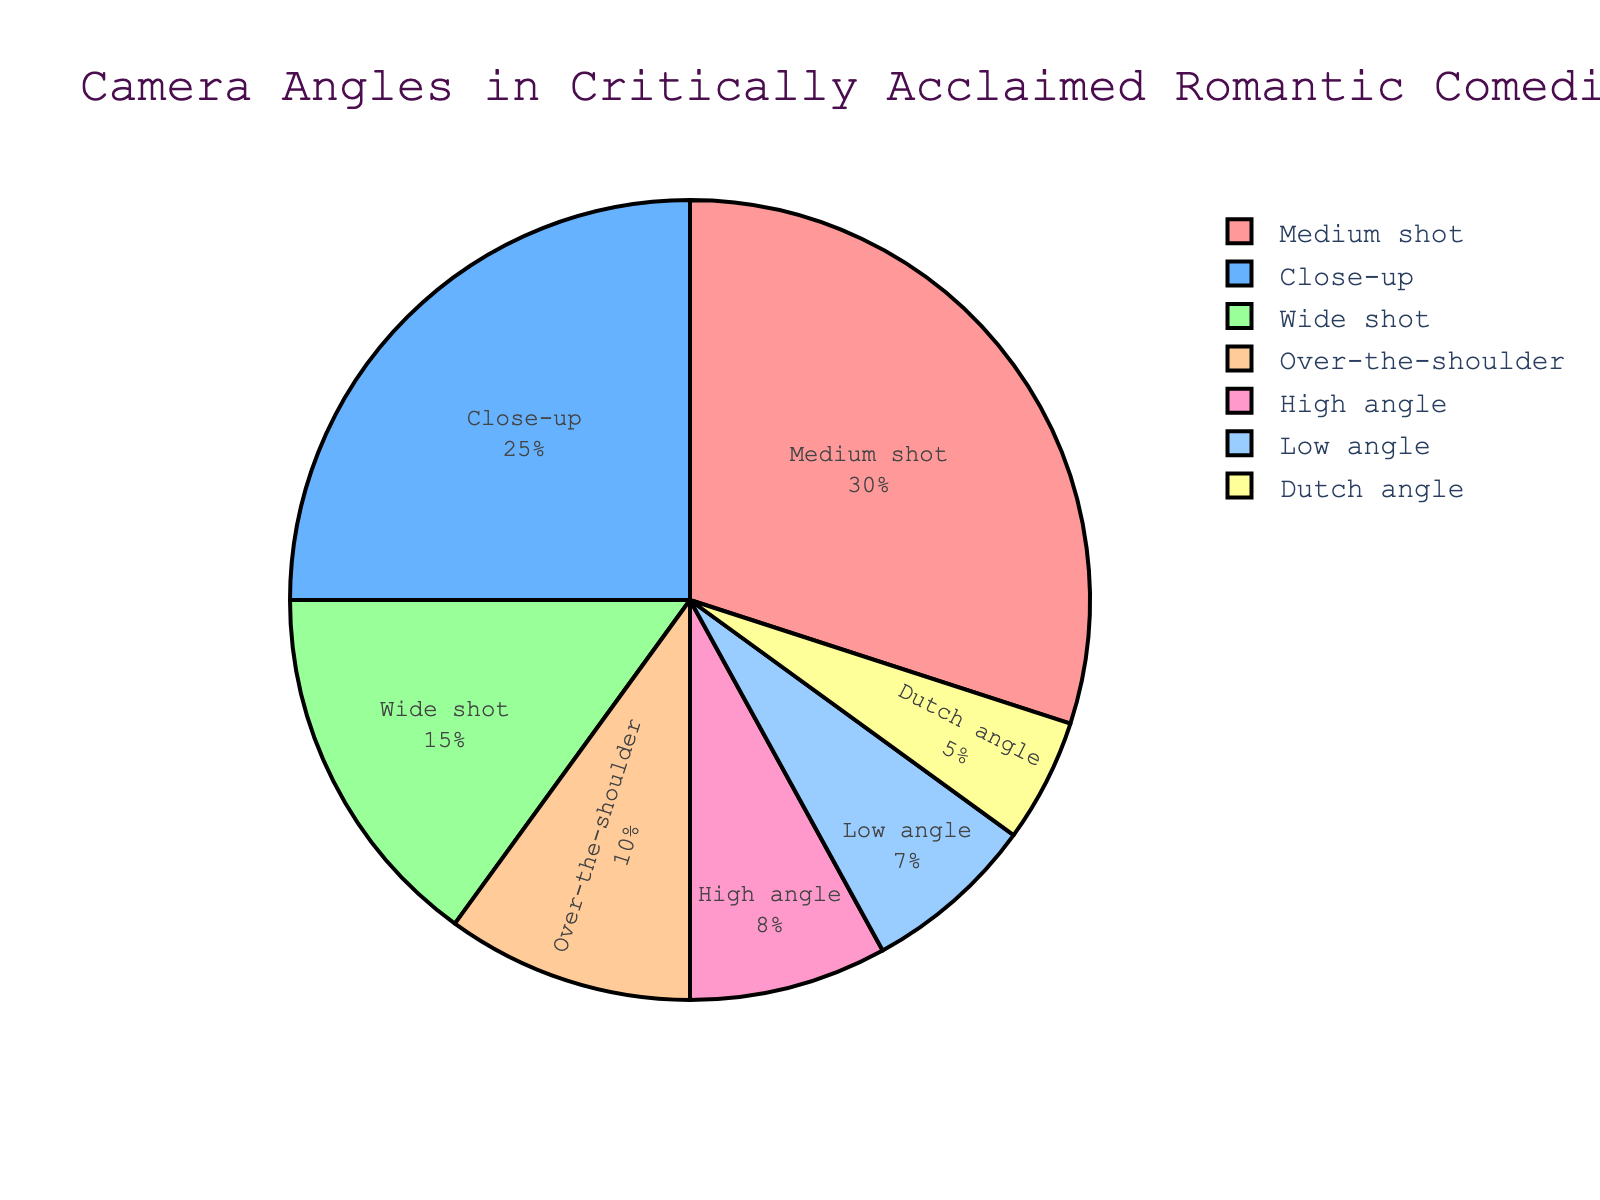What is the most frequently used camera angle in critically acclaimed romantic comedies? The figure shows the camera angles and their respective proportions. The camera angle with the highest percentage is the most frequently used one. The "Medium shot" has the highest percentage at 30%.
Answer: Medium shot Which camera angle has the smallest proportion? By looking at the pie chart, the segment with the smallest percentage corresponds to the "Dutch angle," which has a 5% share.
Answer: Dutch angle What is the combined percentage of Close-up and Medium shot angles? The Close-up angle is 25% and the Medium shot angle is 30%. The combined percentage is 25% + 30% = 55%.
Answer: 55% How do the percentages of High angle and Low angle compare to each other? The pie chart shows that the High angle is 8% and the Low angle is 7%. Therefore, the High angle is 1% more than the Low angle.
Answer: High angle is 1% more Which camera angles together make up exactly half of the camera angle usage? The percentages given are Close-up (25%), Medium shot (30%), Wide shot (15%), Over-the-shoulder (10%), Dutch angle (5%), Low angle (7%), and High angle (8%). Summing up, Close-up (25%) and Medium shot (30%) together make 55%, so we need a combination to sum up 50%. Close-up (25%) + Over-the-shoulder (10%) + Low angle (7%) + High angle (8%) = 50%.
Answer: Close-up, Over-the-shoulder, Low angle, High angle What percentage of camera angles combined fall under other than Close-up, Medium shot, and Wide shot? The total percentage of all camera angles is 100%. Subtract the combined percentage of Close-up (25%), Medium shot (30%), and Wide shot (15%) from 100%. So, it is 100% - (25% + 30% + 15%) = 100% - 70% = 30%.
Answer: 30% Which colors are used for Over-the-shoulder and Dutch angle segments? The Over-the-shoulder segment is shown in a shade of pink (according to the position and color sequence in the legend that assigns colors). The Dutch angle segment is represented in a pinkish color, indicating the assigned color per the chart's color palette.
Answer: Shades of pink What is the difference between the highest and the lowest percentage camera angle usage? The highest percentage is for Medium shot, which is 30%, and the lowest is for Dutch angle, which is 5%. The difference is 30% - 5% = 25%.
Answer: 25% Among the camera angles, which one corresponds to a green segment? Given the provided sequence of colors and chart data, the "Close-up" angle is represented by the green segment.
Answer: Close-up 